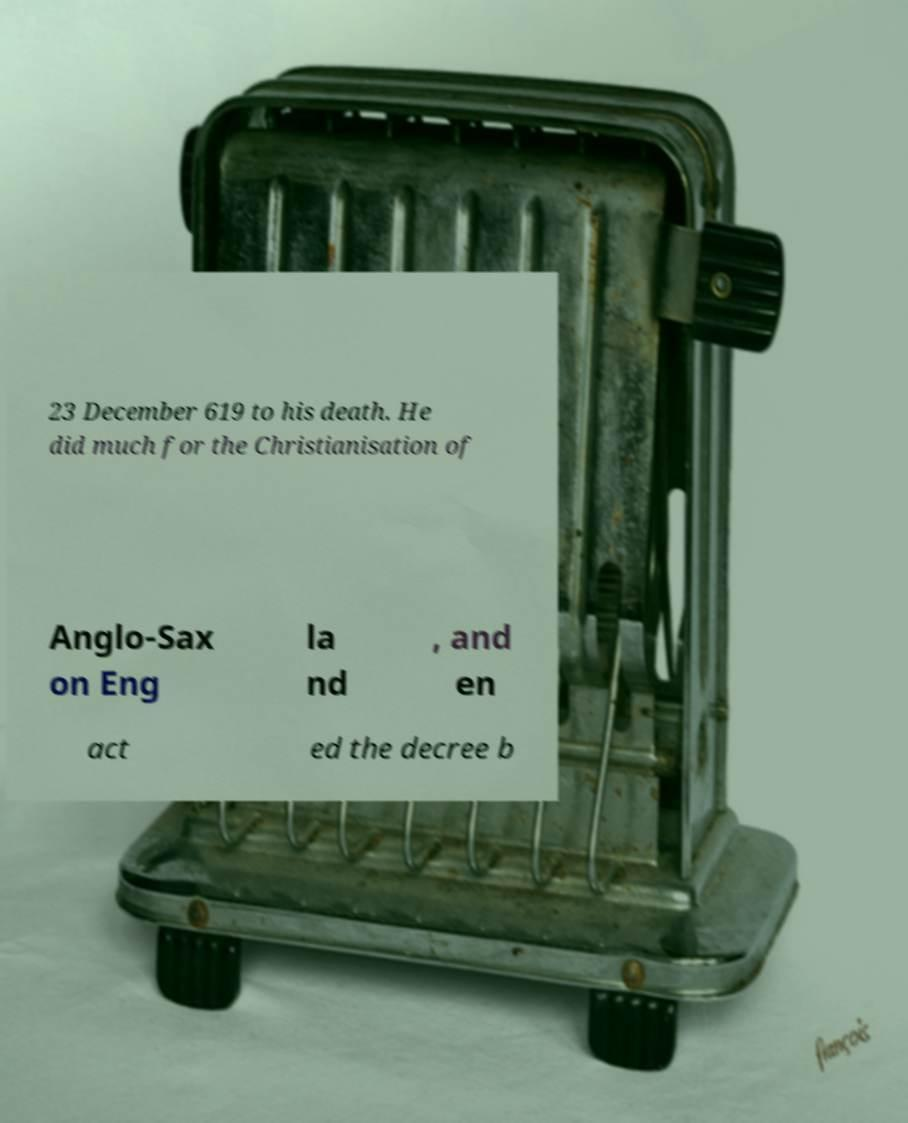Can you accurately transcribe the text from the provided image for me? 23 December 619 to his death. He did much for the Christianisation of Anglo-Sax on Eng la nd , and en act ed the decree b 